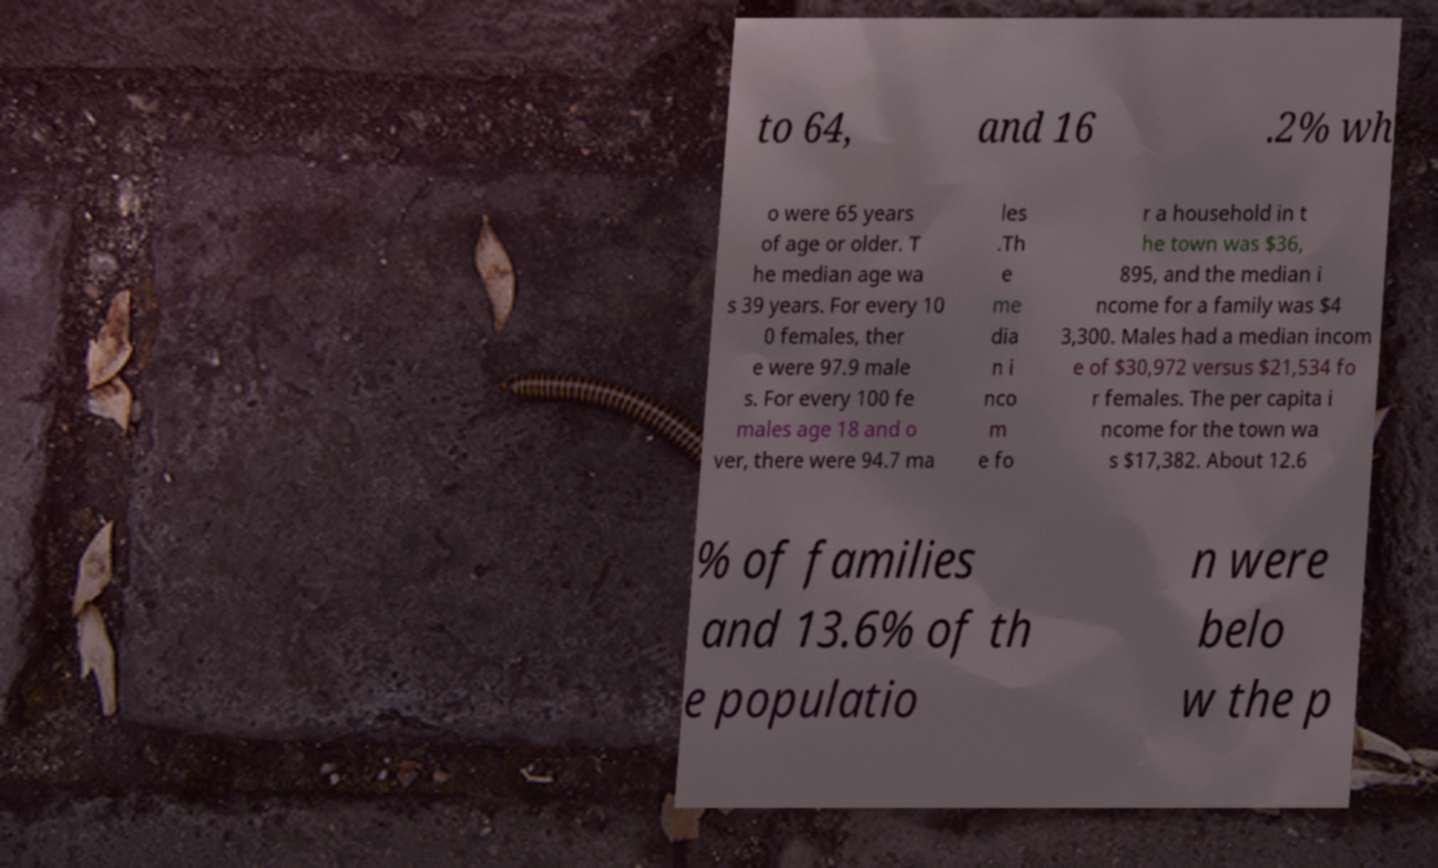Could you assist in decoding the text presented in this image and type it out clearly? to 64, and 16 .2% wh o were 65 years of age or older. T he median age wa s 39 years. For every 10 0 females, ther e were 97.9 male s. For every 100 fe males age 18 and o ver, there were 94.7 ma les .Th e me dia n i nco m e fo r a household in t he town was $36, 895, and the median i ncome for a family was $4 3,300. Males had a median incom e of $30,972 versus $21,534 fo r females. The per capita i ncome for the town wa s $17,382. About 12.6 % of families and 13.6% of th e populatio n were belo w the p 